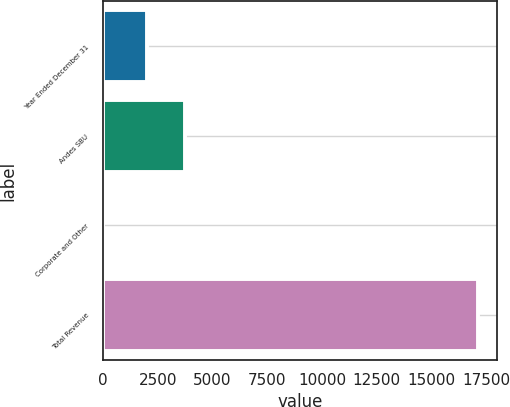<chart> <loc_0><loc_0><loc_500><loc_500><bar_chart><fcel>Year Ended December 31<fcel>Andes SBU<fcel>Corporate and Other<fcel>Total Revenue<nl><fcel>2014<fcel>3728.4<fcel>2<fcel>17146<nl></chart> 